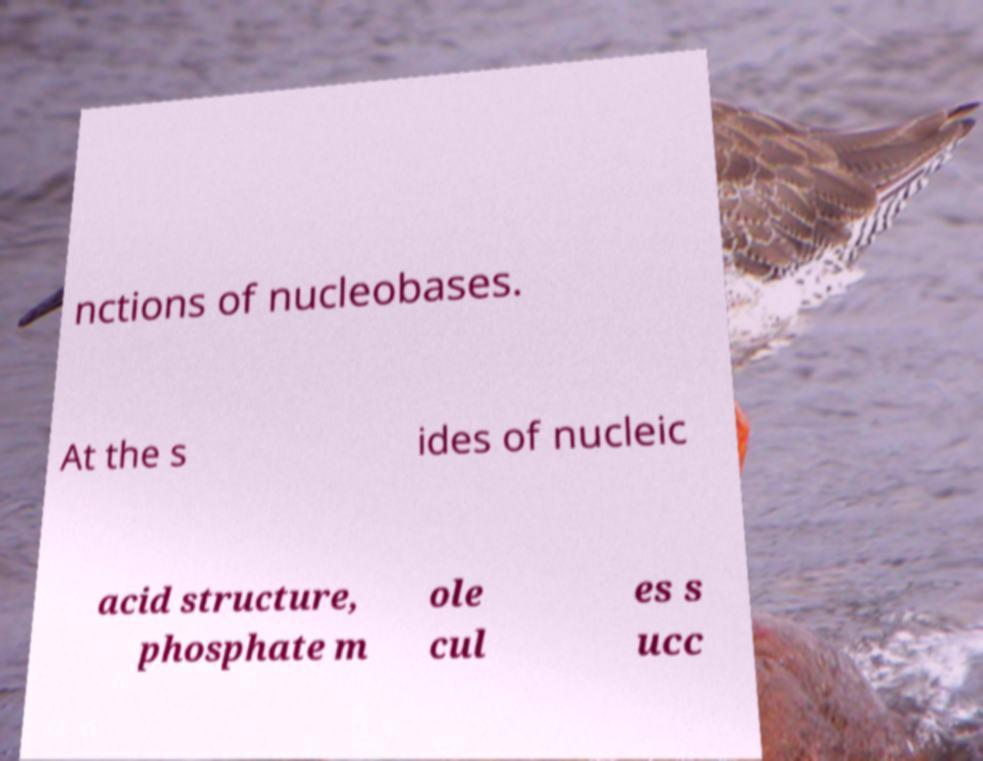Please identify and transcribe the text found in this image. nctions of nucleobases. At the s ides of nucleic acid structure, phosphate m ole cul es s ucc 